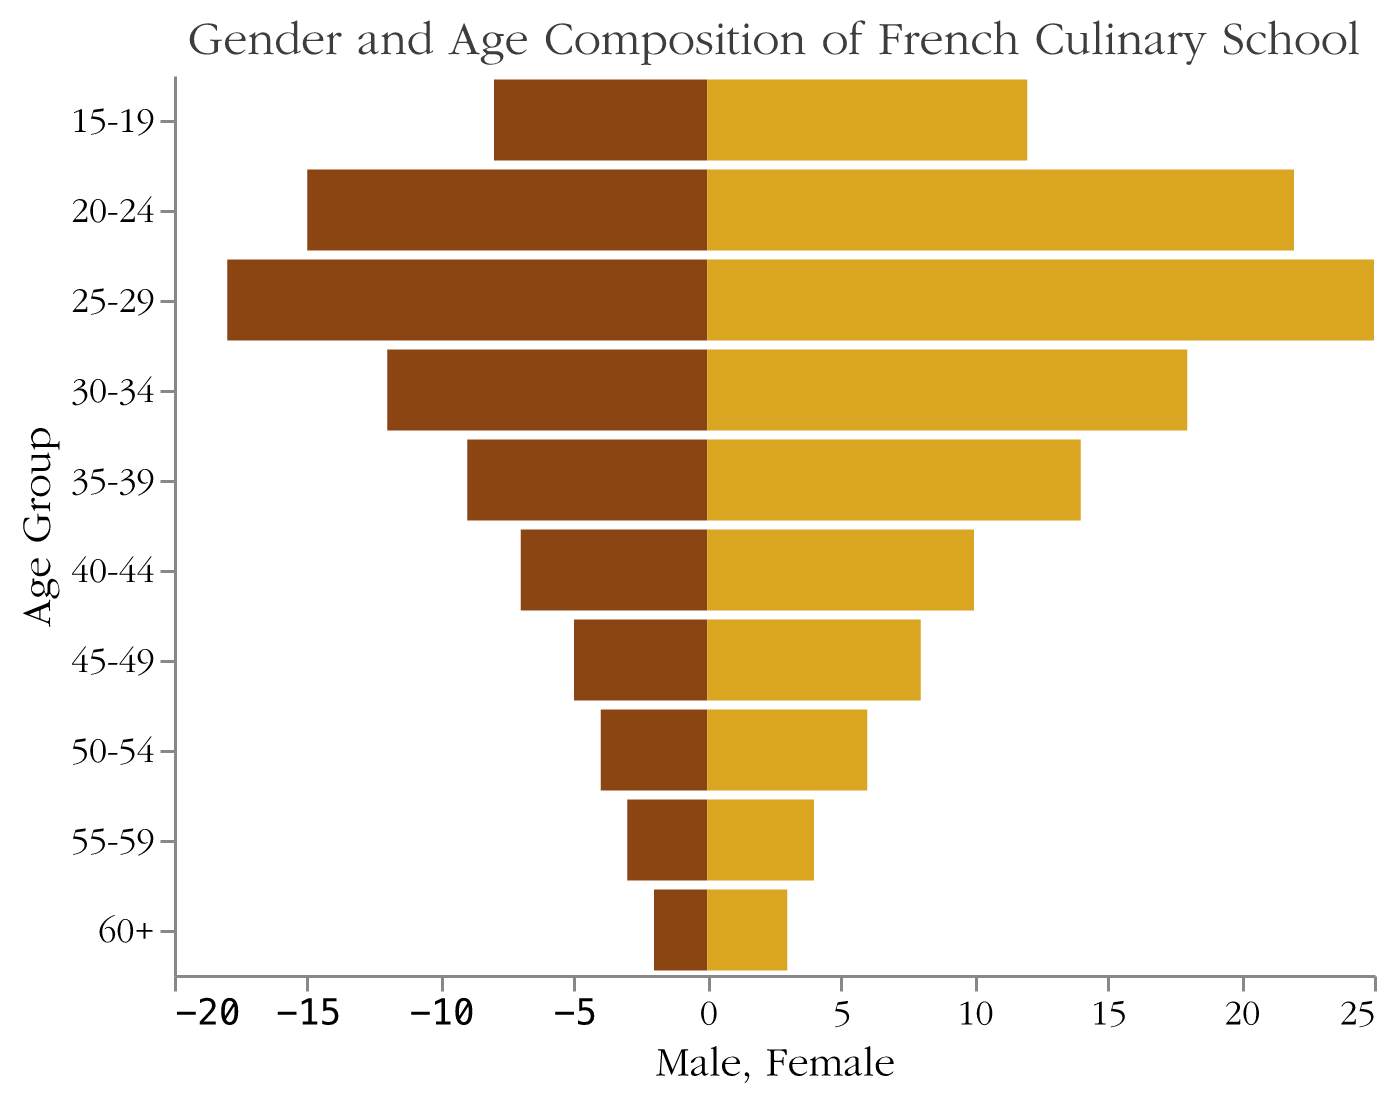What is the title of the figure? The title is usually located at the top of the figure. In this case, it reads "Gender and Age Composition of French Culinary School".
Answer: Gender and Age Composition of French Culinary School Which age group has the highest number of females? By comparing each female bar in the figure, the age group 25-29 stands out as having the longest bar for females.
Answer: 25-29 In which age group is the gender gap (difference between male and female counts) the largest? The age group with the largest gender gap is the one where the difference between the lengths of the male and female bars is greatest. For the 25-29 age group, there are 18 males and 25 females, making the difference 7.
Answer: 25-29 What is the total number of students in the 20-24 age group? Sum the number of males and females in the 20-24 age group: 15 males + 22 females = 37.
Answer: 37 Which gender has more students overall? Add the counts of all males and females across all age groups to compare. Males: 8 + 15 + 18 + 12 + 9 + 7 + 5 + 4 + 3 + 2 = 83; Females: 12 + 22 + 25 + 18 + 14 + 10 + 8 + 6 + 4 + 3 = 122. Females have more students overall.
Answer: Female What is the difference in the number of male and female students in the 40-44 age group? Compare the lengths of the male and female bars for the 40-44 age group: 10 females - 7 males = 3.
Answer: 3 In which age group is the male count exactly half of the female count? Check each age group to see when the number of males is half of the females. In the 15-19 age group, there are 8 males and 12 females. Half of 12 is 6, not 8. Upon checking all groups, none fit the condition exactly.
Answer: None What age group has the smallest number of male students? By observing the lengths of the male bars, the age group 60+ has the smallest male count, with 2 students.
Answer: 60+ How many total students are in the age group 55-59? Add the number of males and females in the 55-59 age group: 3 males + 4 females = 7.
Answer: 7 Which age group has exactly twice as many females as males? By comparing the counts in each age group, the 35-39 age group meets this condition, with 9 males and 14 females.
Answer: 35-39 